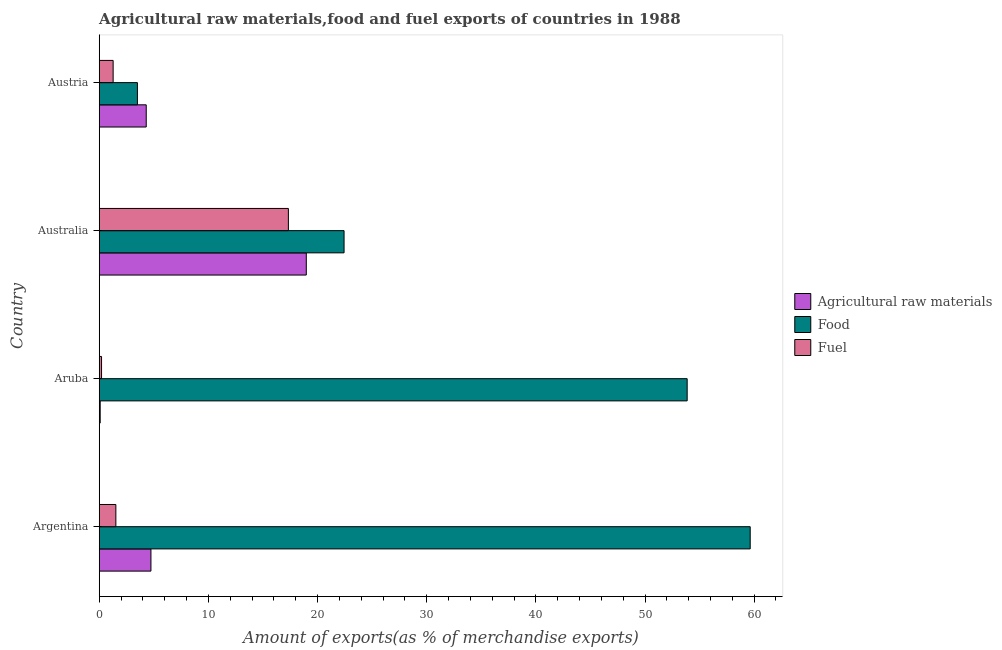How many different coloured bars are there?
Your answer should be compact. 3. How many groups of bars are there?
Ensure brevity in your answer.  4. Are the number of bars on each tick of the Y-axis equal?
Provide a short and direct response. Yes. How many bars are there on the 3rd tick from the top?
Offer a very short reply. 3. In how many cases, is the number of bars for a given country not equal to the number of legend labels?
Give a very brief answer. 0. What is the percentage of food exports in Argentina?
Provide a short and direct response. 59.64. Across all countries, what is the maximum percentage of raw materials exports?
Give a very brief answer. 18.97. Across all countries, what is the minimum percentage of raw materials exports?
Offer a very short reply. 0.09. In which country was the percentage of food exports maximum?
Your response must be concise. Argentina. In which country was the percentage of raw materials exports minimum?
Make the answer very short. Aruba. What is the total percentage of raw materials exports in the graph?
Your answer should be compact. 28.11. What is the difference between the percentage of raw materials exports in Aruba and that in Australia?
Offer a terse response. -18.88. What is the difference between the percentage of raw materials exports in Argentina and the percentage of food exports in Aruba?
Your answer should be very brief. -49.13. What is the average percentage of food exports per country?
Your answer should be very brief. 34.86. What is the difference between the percentage of fuel exports and percentage of raw materials exports in Argentina?
Offer a very short reply. -3.21. In how many countries, is the percentage of fuel exports greater than 40 %?
Provide a short and direct response. 0. What is the ratio of the percentage of food exports in Argentina to that in Aruba?
Offer a terse response. 1.11. What is the difference between the highest and the second highest percentage of food exports?
Your answer should be very brief. 5.78. What is the difference between the highest and the lowest percentage of food exports?
Provide a succinct answer. 56.14. Is the sum of the percentage of fuel exports in Argentina and Austria greater than the maximum percentage of food exports across all countries?
Your response must be concise. No. What does the 1st bar from the top in Australia represents?
Your answer should be compact. Fuel. What does the 3rd bar from the bottom in Austria represents?
Your response must be concise. Fuel. Is it the case that in every country, the sum of the percentage of raw materials exports and percentage of food exports is greater than the percentage of fuel exports?
Give a very brief answer. Yes. How many bars are there?
Offer a very short reply. 12. Are all the bars in the graph horizontal?
Offer a terse response. Yes. How many countries are there in the graph?
Provide a succinct answer. 4. Does the graph contain any zero values?
Make the answer very short. No. What is the title of the graph?
Keep it short and to the point. Agricultural raw materials,food and fuel exports of countries in 1988. Does "Secondary" appear as one of the legend labels in the graph?
Your answer should be very brief. No. What is the label or title of the X-axis?
Your answer should be very brief. Amount of exports(as % of merchandise exports). What is the Amount of exports(as % of merchandise exports) in Agricultural raw materials in Argentina?
Offer a terse response. 4.74. What is the Amount of exports(as % of merchandise exports) in Food in Argentina?
Your answer should be very brief. 59.64. What is the Amount of exports(as % of merchandise exports) in Fuel in Argentina?
Provide a succinct answer. 1.52. What is the Amount of exports(as % of merchandise exports) in Agricultural raw materials in Aruba?
Provide a succinct answer. 0.09. What is the Amount of exports(as % of merchandise exports) of Food in Aruba?
Keep it short and to the point. 53.86. What is the Amount of exports(as % of merchandise exports) of Fuel in Aruba?
Provide a succinct answer. 0.21. What is the Amount of exports(as % of merchandise exports) of Agricultural raw materials in Australia?
Your answer should be compact. 18.97. What is the Amount of exports(as % of merchandise exports) of Food in Australia?
Your response must be concise. 22.43. What is the Amount of exports(as % of merchandise exports) in Fuel in Australia?
Offer a very short reply. 17.33. What is the Amount of exports(as % of merchandise exports) of Agricultural raw materials in Austria?
Ensure brevity in your answer.  4.31. What is the Amount of exports(as % of merchandise exports) of Food in Austria?
Give a very brief answer. 3.5. What is the Amount of exports(as % of merchandise exports) of Fuel in Austria?
Provide a succinct answer. 1.28. Across all countries, what is the maximum Amount of exports(as % of merchandise exports) in Agricultural raw materials?
Your answer should be very brief. 18.97. Across all countries, what is the maximum Amount of exports(as % of merchandise exports) of Food?
Your answer should be compact. 59.64. Across all countries, what is the maximum Amount of exports(as % of merchandise exports) in Fuel?
Offer a terse response. 17.33. Across all countries, what is the minimum Amount of exports(as % of merchandise exports) of Agricultural raw materials?
Keep it short and to the point. 0.09. Across all countries, what is the minimum Amount of exports(as % of merchandise exports) of Food?
Your answer should be compact. 3.5. Across all countries, what is the minimum Amount of exports(as % of merchandise exports) in Fuel?
Ensure brevity in your answer.  0.21. What is the total Amount of exports(as % of merchandise exports) of Agricultural raw materials in the graph?
Keep it short and to the point. 28.11. What is the total Amount of exports(as % of merchandise exports) of Food in the graph?
Your response must be concise. 139.43. What is the total Amount of exports(as % of merchandise exports) in Fuel in the graph?
Keep it short and to the point. 20.34. What is the difference between the Amount of exports(as % of merchandise exports) in Agricultural raw materials in Argentina and that in Aruba?
Ensure brevity in your answer.  4.65. What is the difference between the Amount of exports(as % of merchandise exports) in Food in Argentina and that in Aruba?
Your answer should be very brief. 5.77. What is the difference between the Amount of exports(as % of merchandise exports) of Fuel in Argentina and that in Aruba?
Offer a very short reply. 1.31. What is the difference between the Amount of exports(as % of merchandise exports) in Agricultural raw materials in Argentina and that in Australia?
Ensure brevity in your answer.  -14.23. What is the difference between the Amount of exports(as % of merchandise exports) in Food in Argentina and that in Australia?
Give a very brief answer. 37.21. What is the difference between the Amount of exports(as % of merchandise exports) of Fuel in Argentina and that in Australia?
Ensure brevity in your answer.  -15.81. What is the difference between the Amount of exports(as % of merchandise exports) in Agricultural raw materials in Argentina and that in Austria?
Give a very brief answer. 0.43. What is the difference between the Amount of exports(as % of merchandise exports) in Food in Argentina and that in Austria?
Your response must be concise. 56.14. What is the difference between the Amount of exports(as % of merchandise exports) of Fuel in Argentina and that in Austria?
Keep it short and to the point. 0.25. What is the difference between the Amount of exports(as % of merchandise exports) of Agricultural raw materials in Aruba and that in Australia?
Ensure brevity in your answer.  -18.88. What is the difference between the Amount of exports(as % of merchandise exports) of Food in Aruba and that in Australia?
Your answer should be very brief. 31.43. What is the difference between the Amount of exports(as % of merchandise exports) in Fuel in Aruba and that in Australia?
Your response must be concise. -17.12. What is the difference between the Amount of exports(as % of merchandise exports) in Agricultural raw materials in Aruba and that in Austria?
Keep it short and to the point. -4.22. What is the difference between the Amount of exports(as % of merchandise exports) of Food in Aruba and that in Austria?
Your answer should be compact. 50.36. What is the difference between the Amount of exports(as % of merchandise exports) in Fuel in Aruba and that in Austria?
Provide a short and direct response. -1.06. What is the difference between the Amount of exports(as % of merchandise exports) in Agricultural raw materials in Australia and that in Austria?
Give a very brief answer. 14.66. What is the difference between the Amount of exports(as % of merchandise exports) of Food in Australia and that in Austria?
Make the answer very short. 18.93. What is the difference between the Amount of exports(as % of merchandise exports) of Fuel in Australia and that in Austria?
Offer a very short reply. 16.05. What is the difference between the Amount of exports(as % of merchandise exports) of Agricultural raw materials in Argentina and the Amount of exports(as % of merchandise exports) of Food in Aruba?
Your response must be concise. -49.13. What is the difference between the Amount of exports(as % of merchandise exports) of Agricultural raw materials in Argentina and the Amount of exports(as % of merchandise exports) of Fuel in Aruba?
Your answer should be very brief. 4.52. What is the difference between the Amount of exports(as % of merchandise exports) of Food in Argentina and the Amount of exports(as % of merchandise exports) of Fuel in Aruba?
Provide a succinct answer. 59.43. What is the difference between the Amount of exports(as % of merchandise exports) of Agricultural raw materials in Argentina and the Amount of exports(as % of merchandise exports) of Food in Australia?
Make the answer very short. -17.69. What is the difference between the Amount of exports(as % of merchandise exports) in Agricultural raw materials in Argentina and the Amount of exports(as % of merchandise exports) in Fuel in Australia?
Your answer should be very brief. -12.59. What is the difference between the Amount of exports(as % of merchandise exports) of Food in Argentina and the Amount of exports(as % of merchandise exports) of Fuel in Australia?
Your answer should be very brief. 42.31. What is the difference between the Amount of exports(as % of merchandise exports) in Agricultural raw materials in Argentina and the Amount of exports(as % of merchandise exports) in Food in Austria?
Your response must be concise. 1.24. What is the difference between the Amount of exports(as % of merchandise exports) of Agricultural raw materials in Argentina and the Amount of exports(as % of merchandise exports) of Fuel in Austria?
Offer a terse response. 3.46. What is the difference between the Amount of exports(as % of merchandise exports) of Food in Argentina and the Amount of exports(as % of merchandise exports) of Fuel in Austria?
Provide a succinct answer. 58.36. What is the difference between the Amount of exports(as % of merchandise exports) in Agricultural raw materials in Aruba and the Amount of exports(as % of merchandise exports) in Food in Australia?
Offer a very short reply. -22.34. What is the difference between the Amount of exports(as % of merchandise exports) of Agricultural raw materials in Aruba and the Amount of exports(as % of merchandise exports) of Fuel in Australia?
Your answer should be compact. -17.24. What is the difference between the Amount of exports(as % of merchandise exports) of Food in Aruba and the Amount of exports(as % of merchandise exports) of Fuel in Australia?
Give a very brief answer. 36.53. What is the difference between the Amount of exports(as % of merchandise exports) of Agricultural raw materials in Aruba and the Amount of exports(as % of merchandise exports) of Food in Austria?
Your answer should be very brief. -3.41. What is the difference between the Amount of exports(as % of merchandise exports) in Agricultural raw materials in Aruba and the Amount of exports(as % of merchandise exports) in Fuel in Austria?
Provide a short and direct response. -1.19. What is the difference between the Amount of exports(as % of merchandise exports) in Food in Aruba and the Amount of exports(as % of merchandise exports) in Fuel in Austria?
Your answer should be compact. 52.59. What is the difference between the Amount of exports(as % of merchandise exports) of Agricultural raw materials in Australia and the Amount of exports(as % of merchandise exports) of Food in Austria?
Provide a succinct answer. 15.47. What is the difference between the Amount of exports(as % of merchandise exports) in Agricultural raw materials in Australia and the Amount of exports(as % of merchandise exports) in Fuel in Austria?
Offer a very short reply. 17.7. What is the difference between the Amount of exports(as % of merchandise exports) in Food in Australia and the Amount of exports(as % of merchandise exports) in Fuel in Austria?
Your answer should be compact. 21.16. What is the average Amount of exports(as % of merchandise exports) of Agricultural raw materials per country?
Your answer should be very brief. 7.03. What is the average Amount of exports(as % of merchandise exports) of Food per country?
Provide a short and direct response. 34.86. What is the average Amount of exports(as % of merchandise exports) in Fuel per country?
Make the answer very short. 5.09. What is the difference between the Amount of exports(as % of merchandise exports) in Agricultural raw materials and Amount of exports(as % of merchandise exports) in Food in Argentina?
Ensure brevity in your answer.  -54.9. What is the difference between the Amount of exports(as % of merchandise exports) in Agricultural raw materials and Amount of exports(as % of merchandise exports) in Fuel in Argentina?
Make the answer very short. 3.21. What is the difference between the Amount of exports(as % of merchandise exports) in Food and Amount of exports(as % of merchandise exports) in Fuel in Argentina?
Your response must be concise. 58.11. What is the difference between the Amount of exports(as % of merchandise exports) of Agricultural raw materials and Amount of exports(as % of merchandise exports) of Food in Aruba?
Provide a short and direct response. -53.77. What is the difference between the Amount of exports(as % of merchandise exports) of Agricultural raw materials and Amount of exports(as % of merchandise exports) of Fuel in Aruba?
Offer a very short reply. -0.12. What is the difference between the Amount of exports(as % of merchandise exports) of Food and Amount of exports(as % of merchandise exports) of Fuel in Aruba?
Provide a succinct answer. 53.65. What is the difference between the Amount of exports(as % of merchandise exports) of Agricultural raw materials and Amount of exports(as % of merchandise exports) of Food in Australia?
Offer a very short reply. -3.46. What is the difference between the Amount of exports(as % of merchandise exports) in Agricultural raw materials and Amount of exports(as % of merchandise exports) in Fuel in Australia?
Your response must be concise. 1.64. What is the difference between the Amount of exports(as % of merchandise exports) of Food and Amount of exports(as % of merchandise exports) of Fuel in Australia?
Keep it short and to the point. 5.1. What is the difference between the Amount of exports(as % of merchandise exports) of Agricultural raw materials and Amount of exports(as % of merchandise exports) of Food in Austria?
Keep it short and to the point. 0.81. What is the difference between the Amount of exports(as % of merchandise exports) of Agricultural raw materials and Amount of exports(as % of merchandise exports) of Fuel in Austria?
Ensure brevity in your answer.  3.03. What is the difference between the Amount of exports(as % of merchandise exports) in Food and Amount of exports(as % of merchandise exports) in Fuel in Austria?
Provide a succinct answer. 2.22. What is the ratio of the Amount of exports(as % of merchandise exports) of Agricultural raw materials in Argentina to that in Aruba?
Keep it short and to the point. 53. What is the ratio of the Amount of exports(as % of merchandise exports) of Food in Argentina to that in Aruba?
Keep it short and to the point. 1.11. What is the ratio of the Amount of exports(as % of merchandise exports) of Fuel in Argentina to that in Aruba?
Provide a succinct answer. 7.14. What is the ratio of the Amount of exports(as % of merchandise exports) in Agricultural raw materials in Argentina to that in Australia?
Offer a very short reply. 0.25. What is the ratio of the Amount of exports(as % of merchandise exports) in Food in Argentina to that in Australia?
Keep it short and to the point. 2.66. What is the ratio of the Amount of exports(as % of merchandise exports) of Fuel in Argentina to that in Australia?
Your answer should be very brief. 0.09. What is the ratio of the Amount of exports(as % of merchandise exports) in Agricultural raw materials in Argentina to that in Austria?
Provide a succinct answer. 1.1. What is the ratio of the Amount of exports(as % of merchandise exports) of Food in Argentina to that in Austria?
Your response must be concise. 17.04. What is the ratio of the Amount of exports(as % of merchandise exports) of Fuel in Argentina to that in Austria?
Your response must be concise. 1.2. What is the ratio of the Amount of exports(as % of merchandise exports) of Agricultural raw materials in Aruba to that in Australia?
Provide a short and direct response. 0. What is the ratio of the Amount of exports(as % of merchandise exports) of Food in Aruba to that in Australia?
Your answer should be very brief. 2.4. What is the ratio of the Amount of exports(as % of merchandise exports) of Fuel in Aruba to that in Australia?
Your answer should be compact. 0.01. What is the ratio of the Amount of exports(as % of merchandise exports) of Agricultural raw materials in Aruba to that in Austria?
Provide a short and direct response. 0.02. What is the ratio of the Amount of exports(as % of merchandise exports) of Food in Aruba to that in Austria?
Ensure brevity in your answer.  15.39. What is the ratio of the Amount of exports(as % of merchandise exports) of Fuel in Aruba to that in Austria?
Your answer should be very brief. 0.17. What is the ratio of the Amount of exports(as % of merchandise exports) of Agricultural raw materials in Australia to that in Austria?
Ensure brevity in your answer.  4.4. What is the ratio of the Amount of exports(as % of merchandise exports) of Food in Australia to that in Austria?
Offer a very short reply. 6.41. What is the ratio of the Amount of exports(as % of merchandise exports) of Fuel in Australia to that in Austria?
Make the answer very short. 13.58. What is the difference between the highest and the second highest Amount of exports(as % of merchandise exports) of Agricultural raw materials?
Make the answer very short. 14.23. What is the difference between the highest and the second highest Amount of exports(as % of merchandise exports) in Food?
Your response must be concise. 5.77. What is the difference between the highest and the second highest Amount of exports(as % of merchandise exports) of Fuel?
Offer a terse response. 15.81. What is the difference between the highest and the lowest Amount of exports(as % of merchandise exports) in Agricultural raw materials?
Keep it short and to the point. 18.88. What is the difference between the highest and the lowest Amount of exports(as % of merchandise exports) of Food?
Give a very brief answer. 56.14. What is the difference between the highest and the lowest Amount of exports(as % of merchandise exports) in Fuel?
Give a very brief answer. 17.12. 